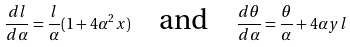Convert formula to latex. <formula><loc_0><loc_0><loc_500><loc_500>\frac { d l } { d \alpha } = \frac { l } { \alpha } ( 1 + 4 \alpha ^ { 2 } x ) \quad \text {and} \quad \frac { d \theta } { d \alpha } = \frac { \theta } { \alpha } + 4 \alpha y l</formula> 